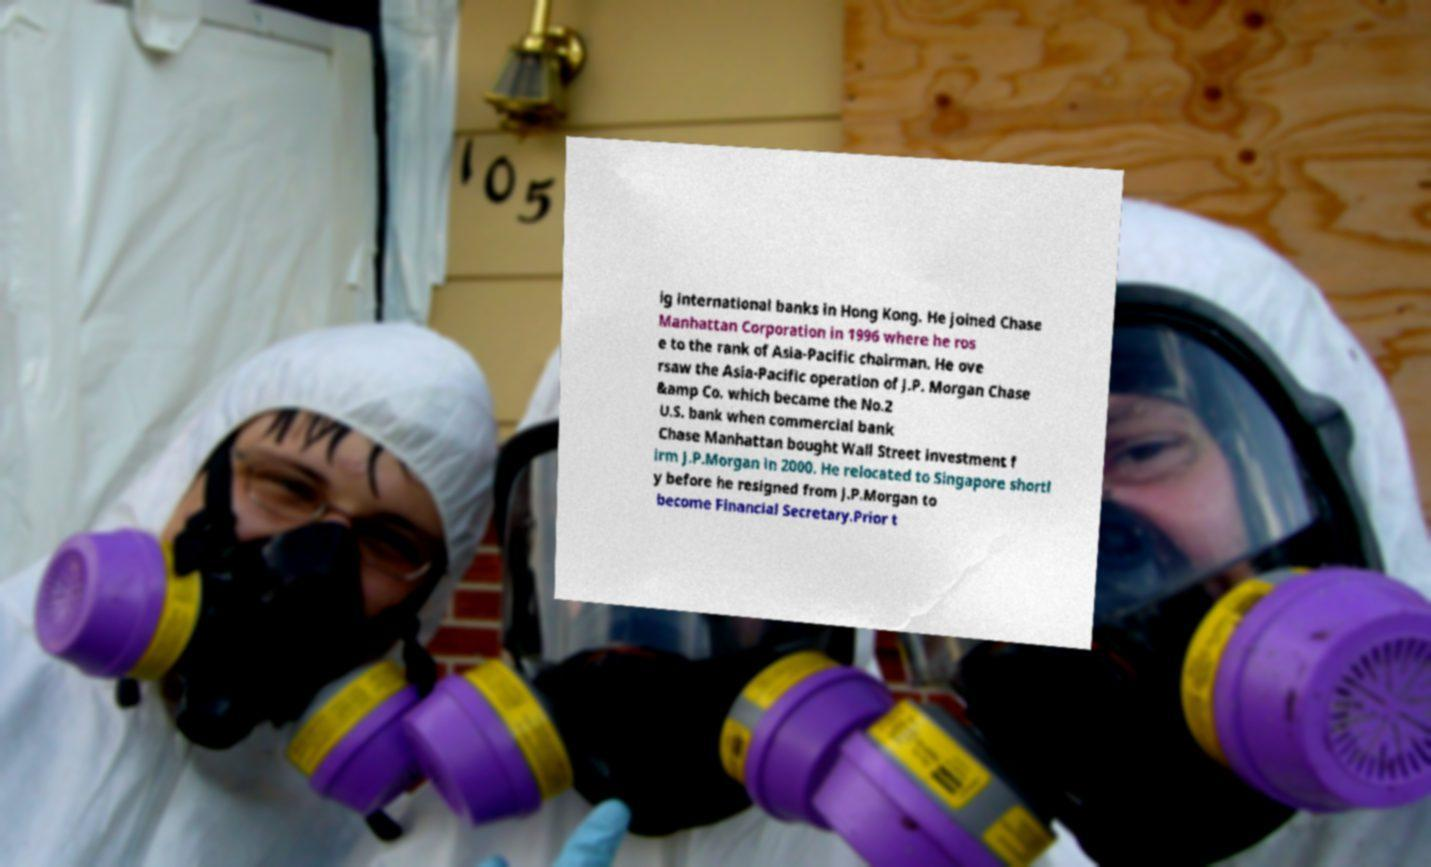Could you extract and type out the text from this image? ig international banks in Hong Kong. He joined Chase Manhattan Corporation in 1996 where he ros e to the rank of Asia-Pacific chairman. He ove rsaw the Asia-Pacific operation of J.P. Morgan Chase &amp Co. which became the No.2 U.S. bank when commercial bank Chase Manhattan bought Wall Street investment f irm J.P.Morgan in 2000. He relocated to Singapore shortl y before he resigned from J.P.Morgan to become Financial Secretary.Prior t 